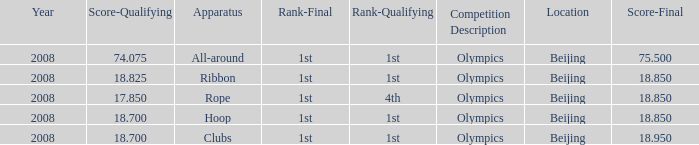On which apparatus did Kanayeva have a final score smaller than 75.5 and a qualifying score smaller than 18.7? Rope. 